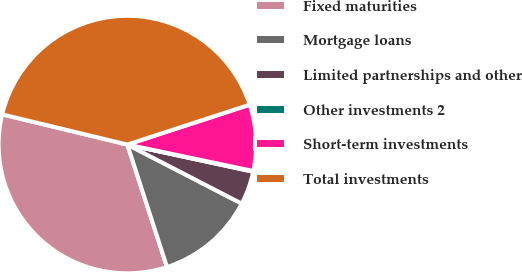Convert chart to OTSL. <chart><loc_0><loc_0><loc_500><loc_500><pie_chart><fcel>Fixed maturities<fcel>Mortgage loans<fcel>Limited partnerships and other<fcel>Other investments 2<fcel>Short-term investments<fcel>Total investments<nl><fcel>33.75%<fcel>12.43%<fcel>4.2%<fcel>0.09%<fcel>8.31%<fcel>41.22%<nl></chart> 